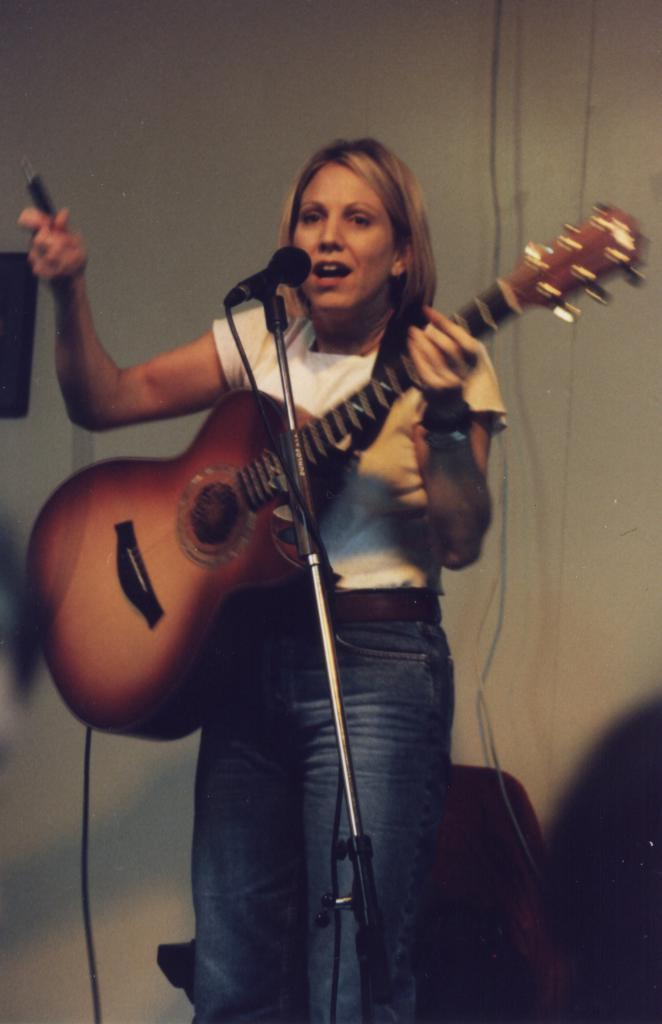Who is the main subject in the image? There is a woman in the image. What is the woman doing in the image? The woman is standing in the image. What object is the woman holding in her hand? The woman is holding a guitar in her hand. What part of the guitar is coiled around the woman's neck in the image? There is no guitar strap coiled around the woman's neck in the image; she is simply holding the guitar in her hand. 